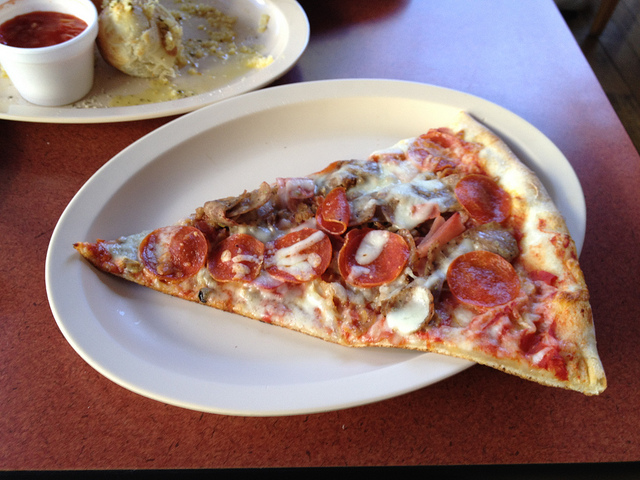Can you elaborate on how the toppings on this pizza contribute to its overall flavor profile? Certainly! The toppings on this pizza are a symphony of flavors. The pepperoni offers a spicy, slightly smoky taste, which harmonizes beautifully with the milder, earthy flavor of the mushrooms. The sausage introduces a robust, meaty essence that enriches the slice, while the onions provide a subtle sharpness that cuts through the richness, offering a refreshing zing. Together, these elements create a balanced and deeply satisfying flavor profile that tantalizes the palate. 